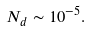Convert formula to latex. <formula><loc_0><loc_0><loc_500><loc_500>N _ { d } \sim 1 0 ^ { - 5 } .</formula> 